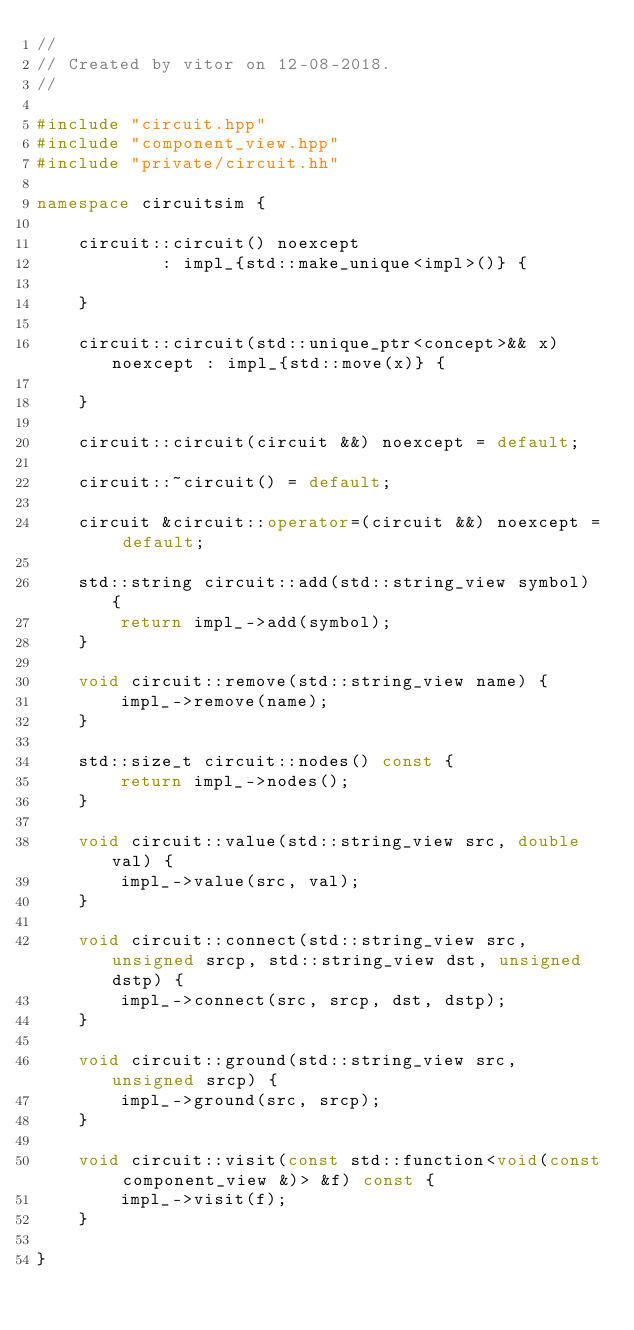Convert code to text. <code><loc_0><loc_0><loc_500><loc_500><_C++_>//
// Created by vitor on 12-08-2018.
//

#include "circuit.hpp"
#include "component_view.hpp"
#include "private/circuit.hh"

namespace circuitsim {

    circuit::circuit() noexcept
            : impl_{std::make_unique<impl>()} {

    }

    circuit::circuit(std::unique_ptr<concept>&& x) noexcept : impl_{std::move(x)} {

    }

    circuit::circuit(circuit &&) noexcept = default;

    circuit::~circuit() = default;

    circuit &circuit::operator=(circuit &&) noexcept = default;

    std::string circuit::add(std::string_view symbol) {
        return impl_->add(symbol);
    }

    void circuit::remove(std::string_view name) {
        impl_->remove(name);
    }

    std::size_t circuit::nodes() const {
        return impl_->nodes();
    }

    void circuit::value(std::string_view src, double val) {
        impl_->value(src, val);
    }

    void circuit::connect(std::string_view src, unsigned srcp, std::string_view dst, unsigned dstp) {
        impl_->connect(src, srcp, dst, dstp);
    }

    void circuit::ground(std::string_view src, unsigned srcp) {
        impl_->ground(src, srcp);
    }

    void circuit::visit(const std::function<void(const component_view &)> &f) const {
        impl_->visit(f);
    }

}</code> 